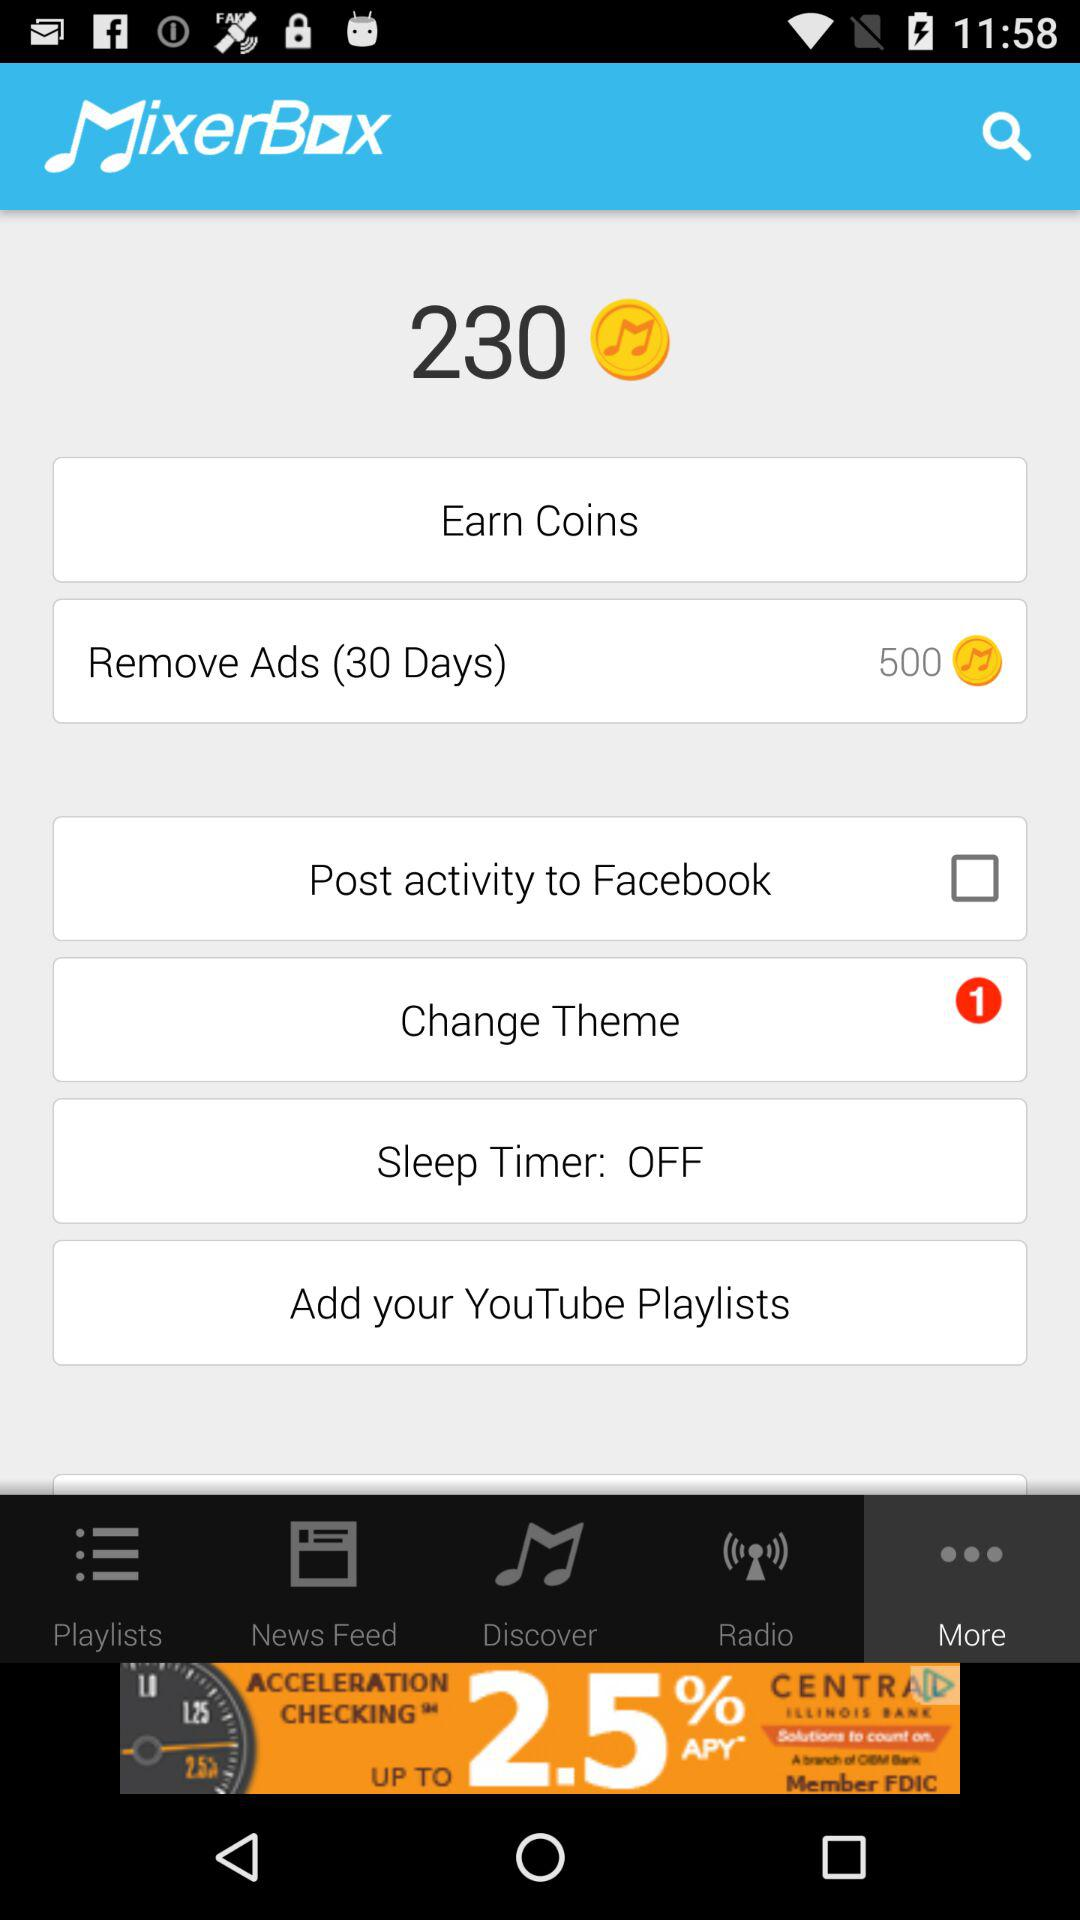Are there any notifications for the "Change Theme"? There is 1 notification. 